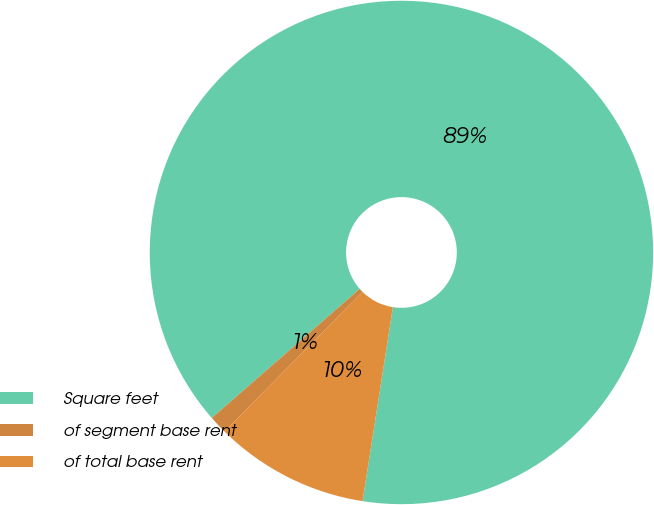Convert chart to OTSL. <chart><loc_0><loc_0><loc_500><loc_500><pie_chart><fcel>Square feet<fcel>of segment base rent<fcel>of total base rent<nl><fcel>88.88%<fcel>1.17%<fcel>9.94%<nl></chart> 